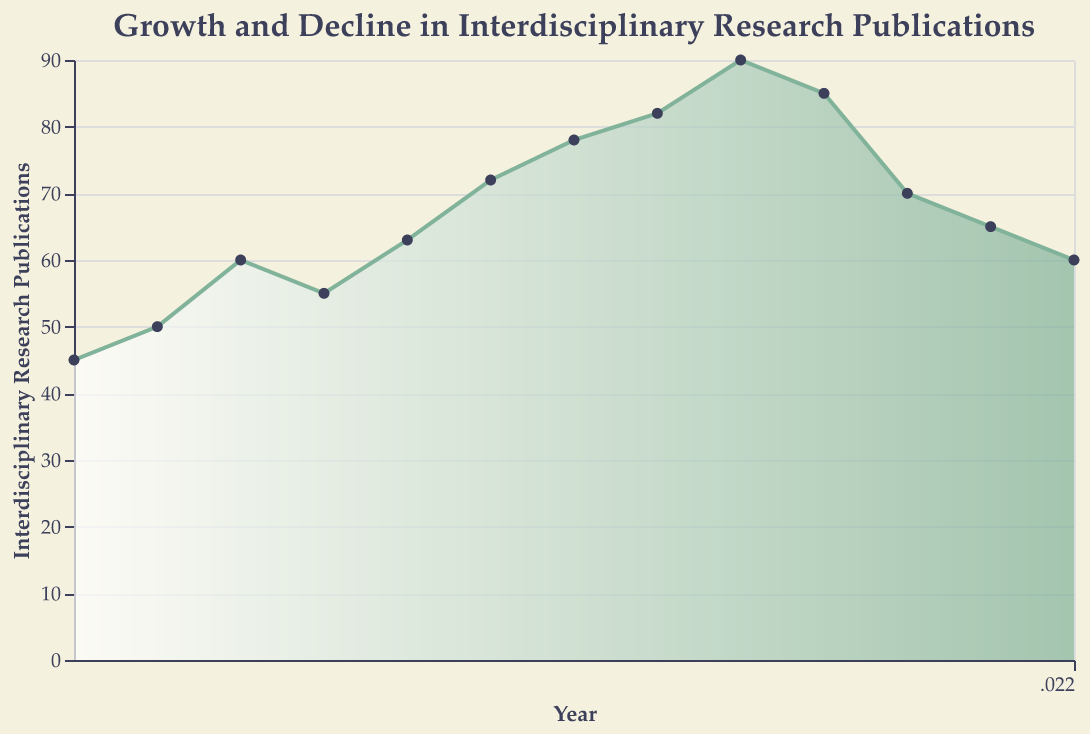What is the title of the area chart? The title is visible at the top of the chart and reads "Growth and Decline in Interdisciplinary Research Publications".
Answer: "Growth and Decline in Interdisciplinary Research Publications" How many years are covered in the area chart? By counting the unique years on the x-axis, the span from 2010 to 2022 is covered, which includes a total of 13 years.
Answer: 13 What is the value for interdisciplinary research publications in 2018? Locate the data point for the year 2018 on the x-axis and find the corresponding value on the y-axis, which is 90.
Answer: 90 In which year did the interdisciplinary research publications peak? Identify the highest data point on the chart, which occurs at its peak in 2018 with a value of 90.
Answer: 2018 By how much did the publications decrease from 2019 to 2020? Find the values for both years: 2019 has 85 publications, and 2020 has 70. Subtract 70 from 85 to get the difference.
Answer: 15 What is the average number of interdisciplinary research publications from 2010 to 2013? Sum the values for the years 2010 to 2013 (45+50+60+55=210) and divide by 4.
Answer: 52.5 Which year had the least number of interdisciplinary research publications? Locate the lowest data point on the chart, occurring in 2010 with 45 publications.
Answer: 2010 What is the overall trend of interdisciplinary research publications from 2010 to 2022? Visual inspection shows publications generally increase until 2018 and then decline thereafter.
Answer: Increase, then decrease By what percentage did the number of publications change from 2017 to 2018? The publications in 2017 were 82, and in 2018, it was 90. Calculate the percentage change: ((90-82)/82)*100.
Answer: 9.76% Describe the trend seen in the number of interdisciplinary research publications between 2016 and 2019. The values are steadily rising from 78 in 2016 to 90 in 2018, followed by a slight drop to 85 in 2019.
Answer: Increase, then slight decrease 